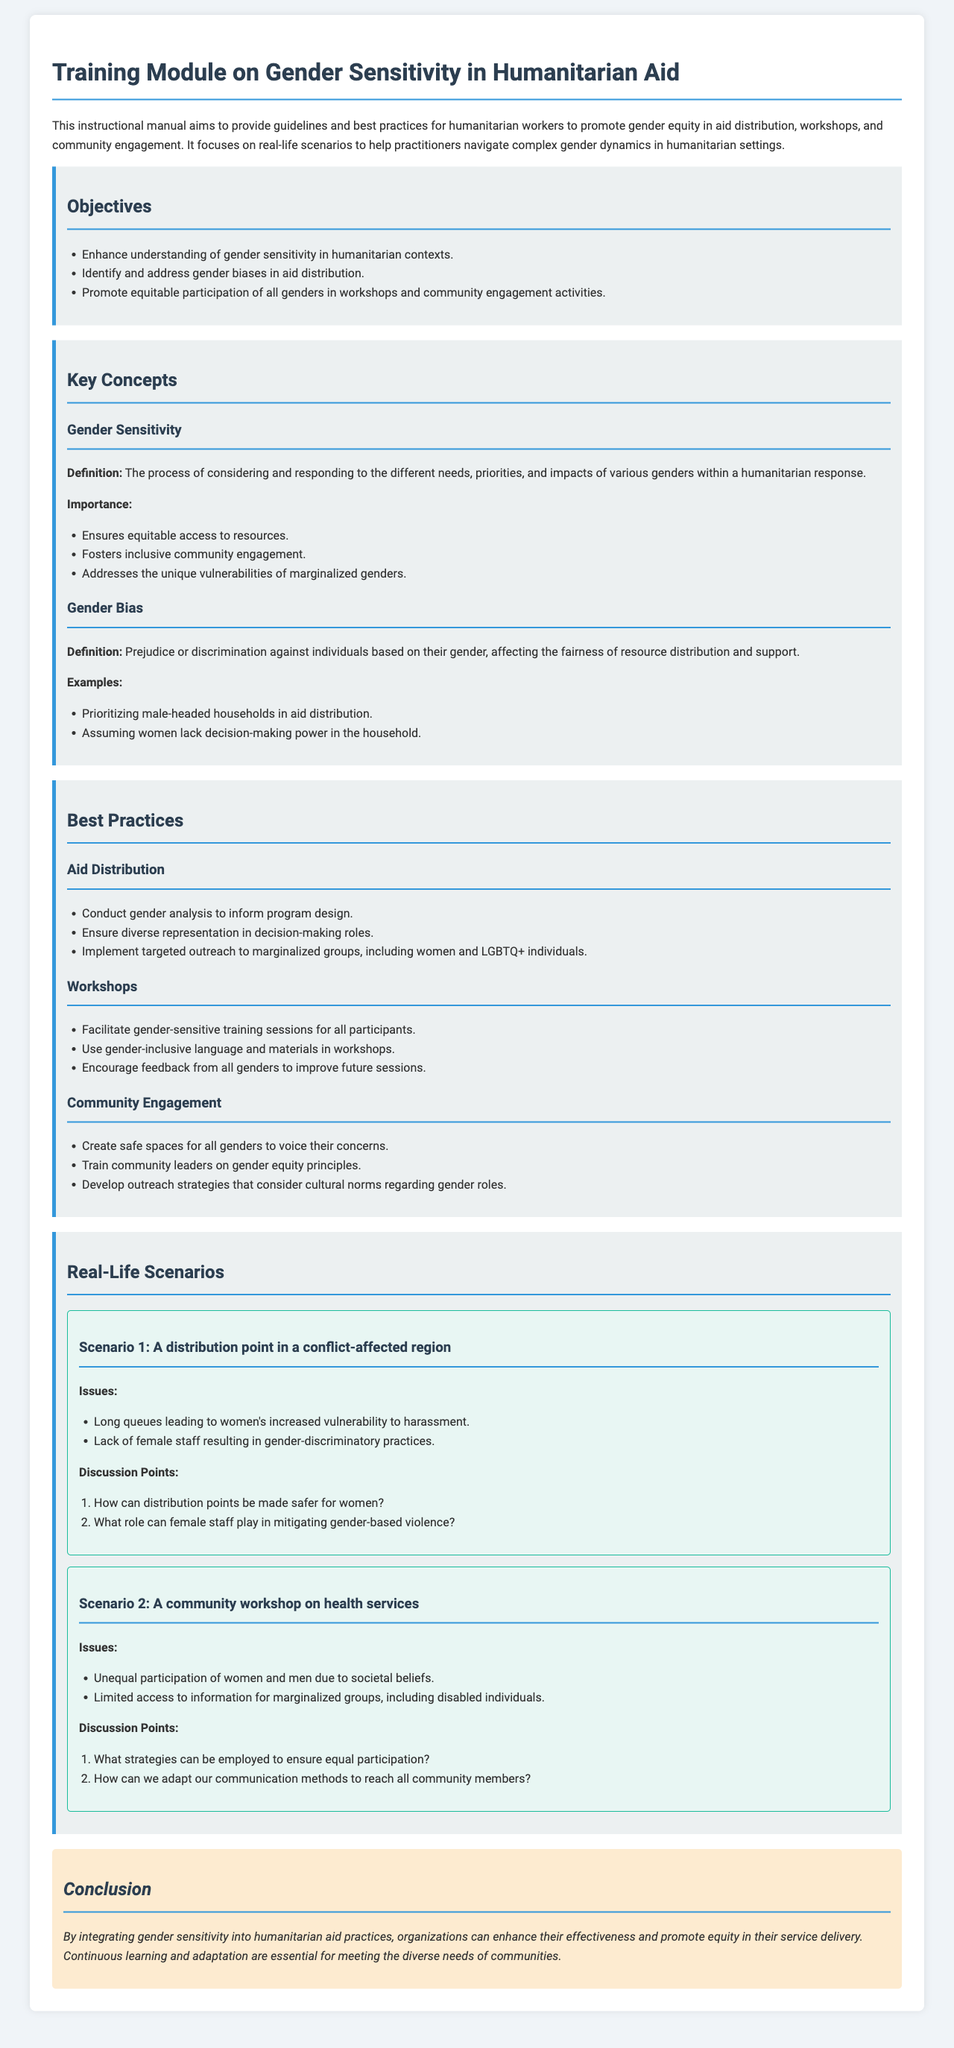What is the title of the manual? The title of the manual is provided at the beginning of the document, which is "Training Module on Gender Sensitivity in Humanitarian Aid."
Answer: Training Module on Gender Sensitivity in Humanitarian Aid What is one objective of the manual? The document lists several objectives under the objectives section, one of which is enhancing understanding of gender sensitivity in humanitarian contexts.
Answer: Enhance understanding of gender sensitivity in humanitarian contexts What does "gender sensitivity" mean? The definition of gender sensitivity is provided in the key concepts section, indicating it as the process of considering and responding to different needs based on gender.
Answer: The process of considering and responding to the different needs, priorities, and impacts of various genders within a humanitarian response Which gender bias example is mentioned in the manual? The document cites "prioritizing male-headed households in aid distribution" as an example of gender bias.
Answer: Prioritizing male-headed households in aid distribution What is one best practice for community engagement? The best practices section includes several suggestions for community engagement, such as creating safe spaces for all genders to voice their concerns.
Answer: Create safe spaces for all genders to voice their concerns How many scenarios are provided in the document? The document outlines two real-life scenarios in the scenarios section.
Answer: Two What issue is highlighted in scenario 1? Scenario 1 discusses issues such as long queues leading to women's increased vulnerability to harassment.
Answer: Long queues leading to women's increased vulnerability to harassment What is a suggested discussion point for scenario 2? The discussion points for scenario 2 include strategies for ensuring equal participation, which aids in addressing gender dynamics.
Answer: What strategies can be employed to ensure equal participation? 